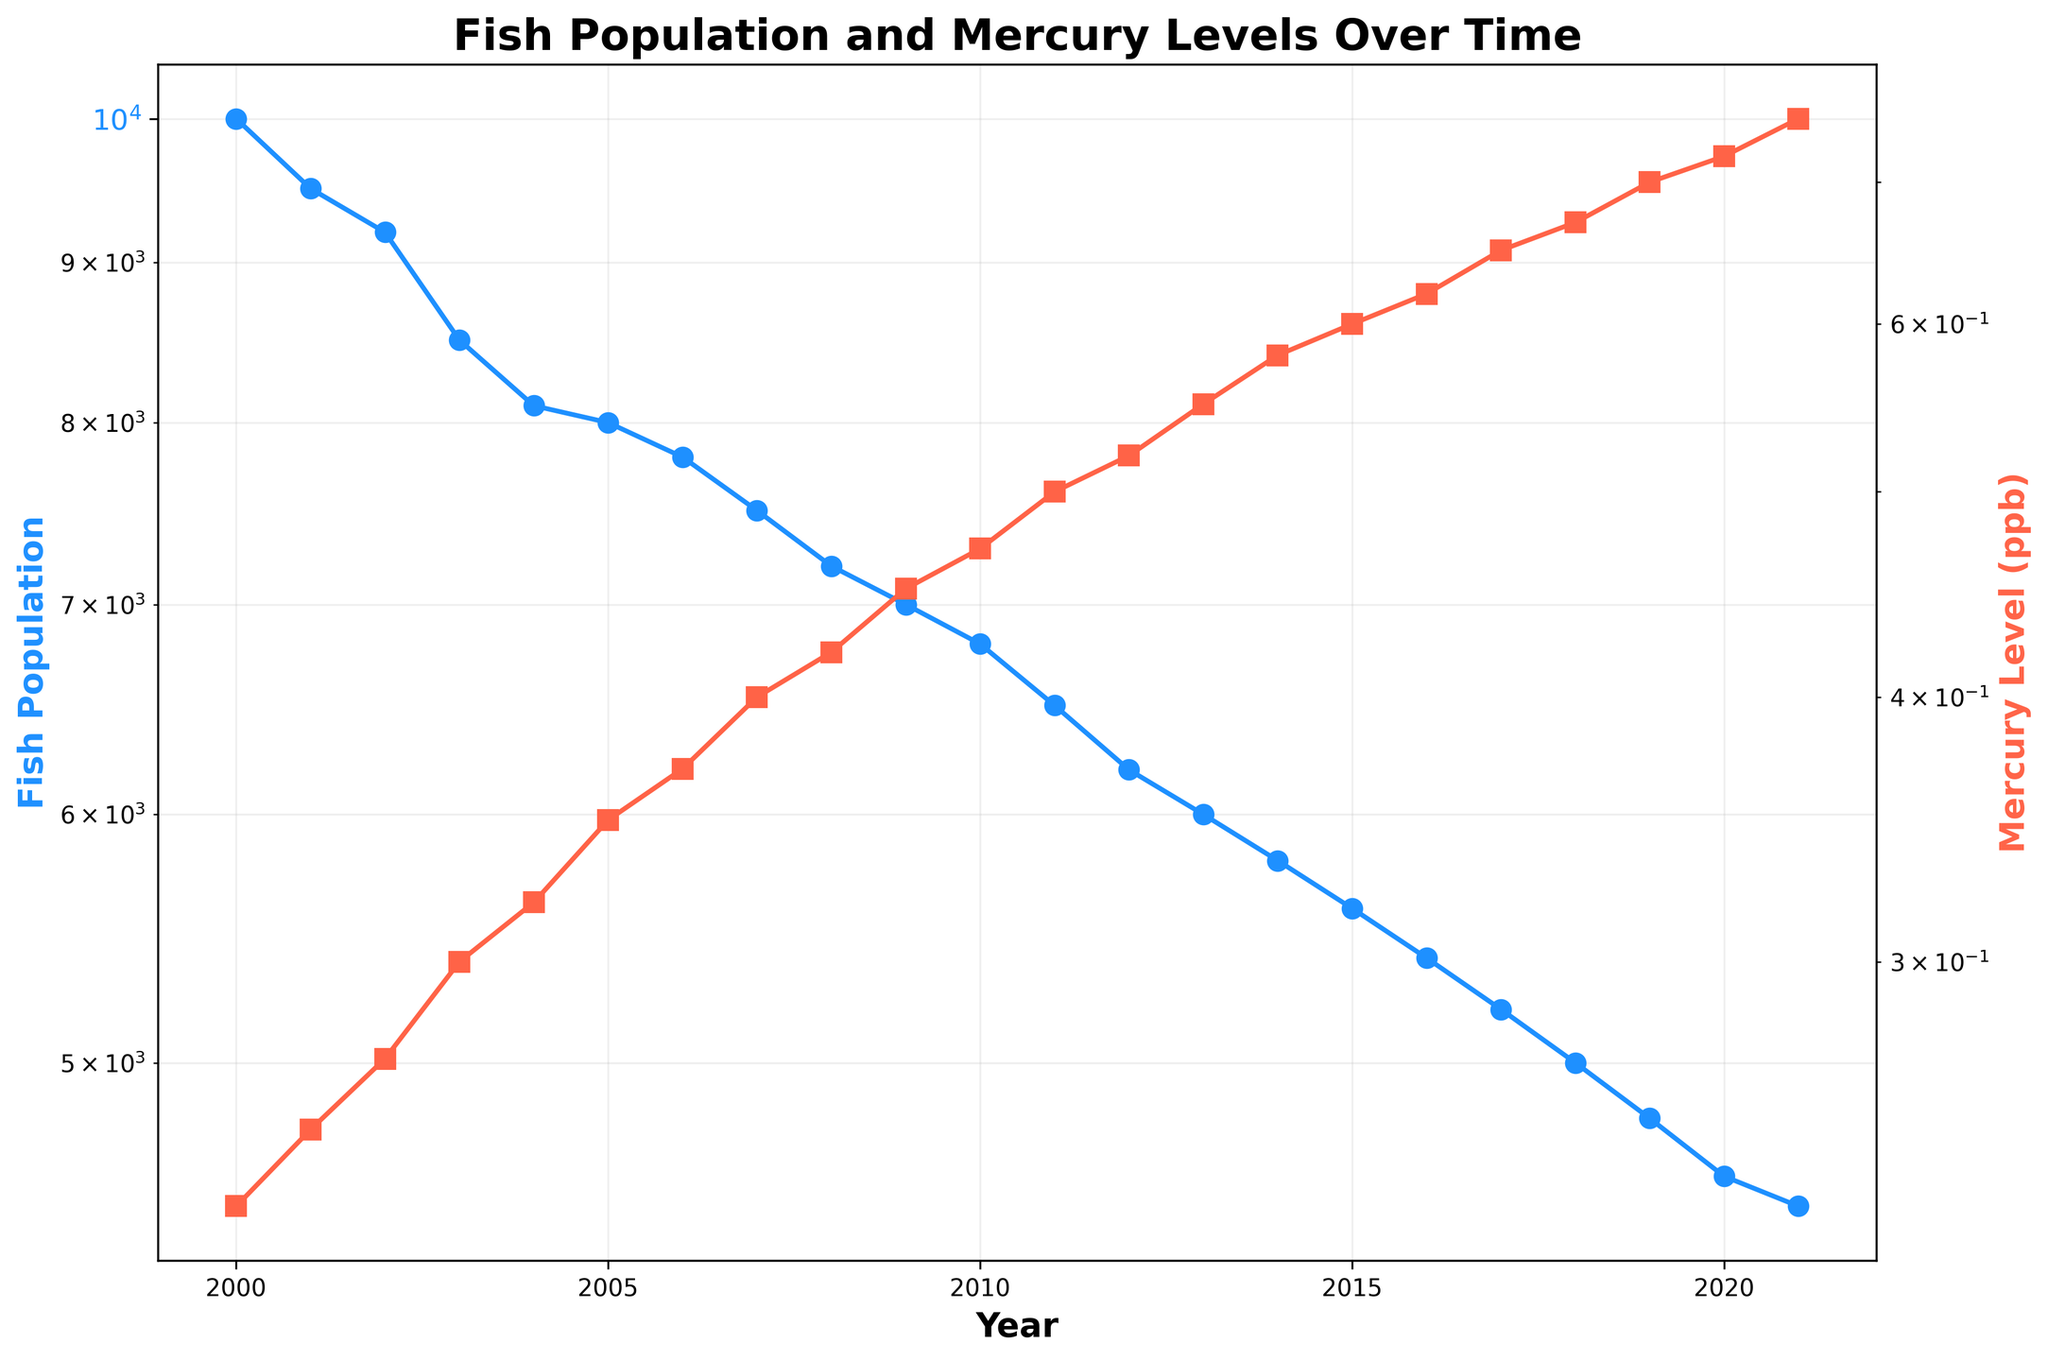What is the title of the figure? The title is usually positioned at the top of the figure and can be read directly.
Answer: Fish Population and Mercury Levels Over Time How many years does the figure cover? The x-axis of the figure represents years, and the figure spans from 2000 to 2021. Counting all the years inclusively, there are 22 data points.
Answer: 22 What color is used to represent the Fish Population data? The color associated with the Fish Population line can be identified directly from the visual attributes in the figure.
Answer: Blue By how much did the Fish Population decrease from the year 2000 to 2021? The Fish Population in 2000 was 10,000, and in 2021 it was 4,500. Subtract the latter from the former to find the decrease. Decrease = 10,000 - 4,500.
Answer: 5,500 What was the highest recorded Mercury Level between 2000 and 2021? Look at the y-axis representing Mercury Level and identify the highest point on the red line. This occurs in the year 2021 with a value of 0.75 ppb.
Answer: 0.75 ppb Which year experienced the largest drop in Fish Population? This requires identifying the steepest decline between two consecutive years in the blue line. The largest drop occurs between 2000 (10,000) and 2001 (9,500), which is a drop of 500.
Answer: 2000 to 2001 Is there a clear trend in the Mercury Level over the years? The red line representing Mercury Level consistently moves upwards from 0.23 ppb in 2000 to 0.75 ppb in 2021, indicating a clear increasing trend.
Answer: Increasing trend How do the Mercury Levels in 2005 and 2015 compare? Locate the points for the years 2005 and 2015 on the red line. In 2005, the Mercury Level was 0.35 ppb, and in 2015 it was 0.60 ppb. The level in 2015 is clearly higher.
Answer: 2015 is higher What is the difference in Fish Population between 2002 and 2012? The Fish Population in 2002 was 9,200, and in 2012 it was 6,200. The difference is calculated as 9,200 - 6,200.
Answer: 3,000 What can we infer about the relationship between Fish Population and Mercury Level over the period? Observing both trends in the figure, we see that as Mercury Levels (red line) increase steadily, the Fish Population (blue line) shows a consistent decrease, suggesting a negative correlation.
Answer: Negative correlation 